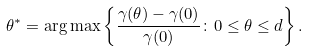<formula> <loc_0><loc_0><loc_500><loc_500>\theta ^ { * } = \arg \max \left \{ \frac { \gamma ( \theta ) - \gamma ( 0 ) } { \gamma ( 0 ) } \colon 0 \leq \theta \leq d \right \} .</formula> 